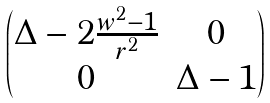Convert formula to latex. <formula><loc_0><loc_0><loc_500><loc_500>\begin{pmatrix} \Delta - 2 \frac { w ^ { 2 } - 1 } { r ^ { 2 } } & 0 \\ 0 & \Delta - 1 \end{pmatrix}</formula> 